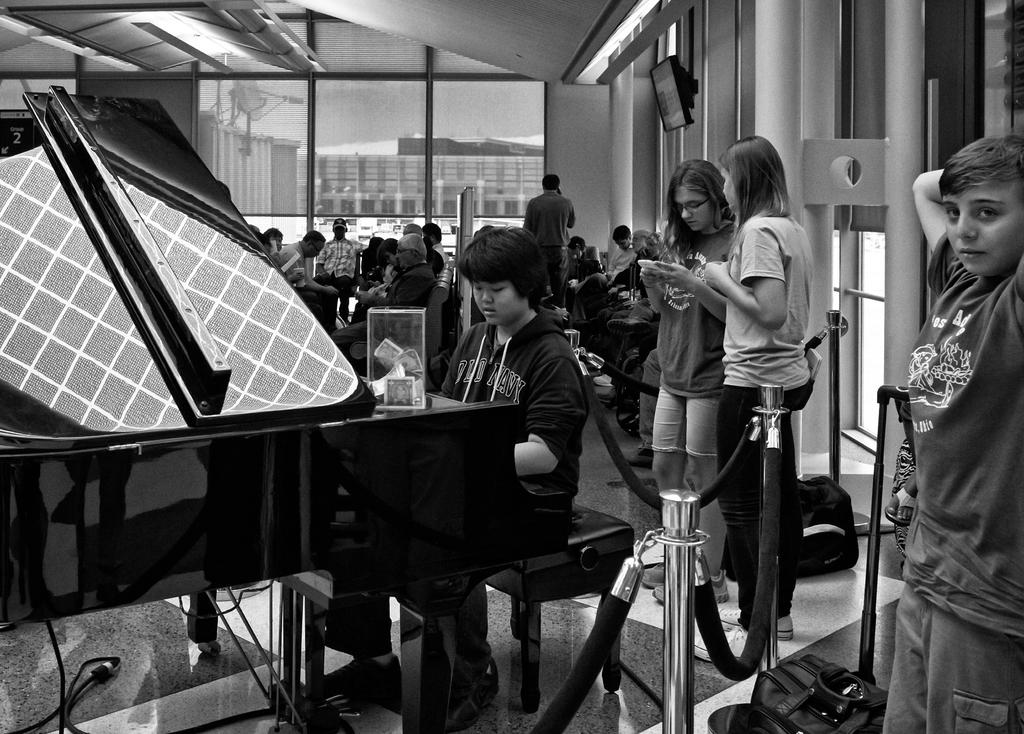How many people are in the image? There are multiple people in the image. What is the position of one of the people in the image? One person is sitting on a stool. What is the person sitting on the stool doing? The person on the stool is in front of a piano. Can you describe the lighting in the image? There is a light on the wall in the image. What type of veil is draped over the piano in the image? There is no veil present in the image; it only features people and a piano. What invention is being demonstrated by the person sitting on the stool? The image does not show any invention being demonstrated; it simply shows a person sitting on a stool in front of a piano. 